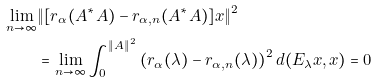<formula> <loc_0><loc_0><loc_500><loc_500>\lim _ { n \rightarrow \infty } & \| [ r _ { \alpha } ( A ^ { * } A ) - r _ { \alpha , n } ( A ^ { * } A ) ] x \| ^ { 2 } \\ & = \lim _ { n \rightarrow \infty } \int _ { 0 } ^ { \| A \| ^ { 2 } } \left ( r _ { \alpha } ( \lambda ) - r _ { \alpha , n } ( \lambda ) \right ) ^ { 2 } d ( E _ { \lambda } x , x ) = 0</formula> 